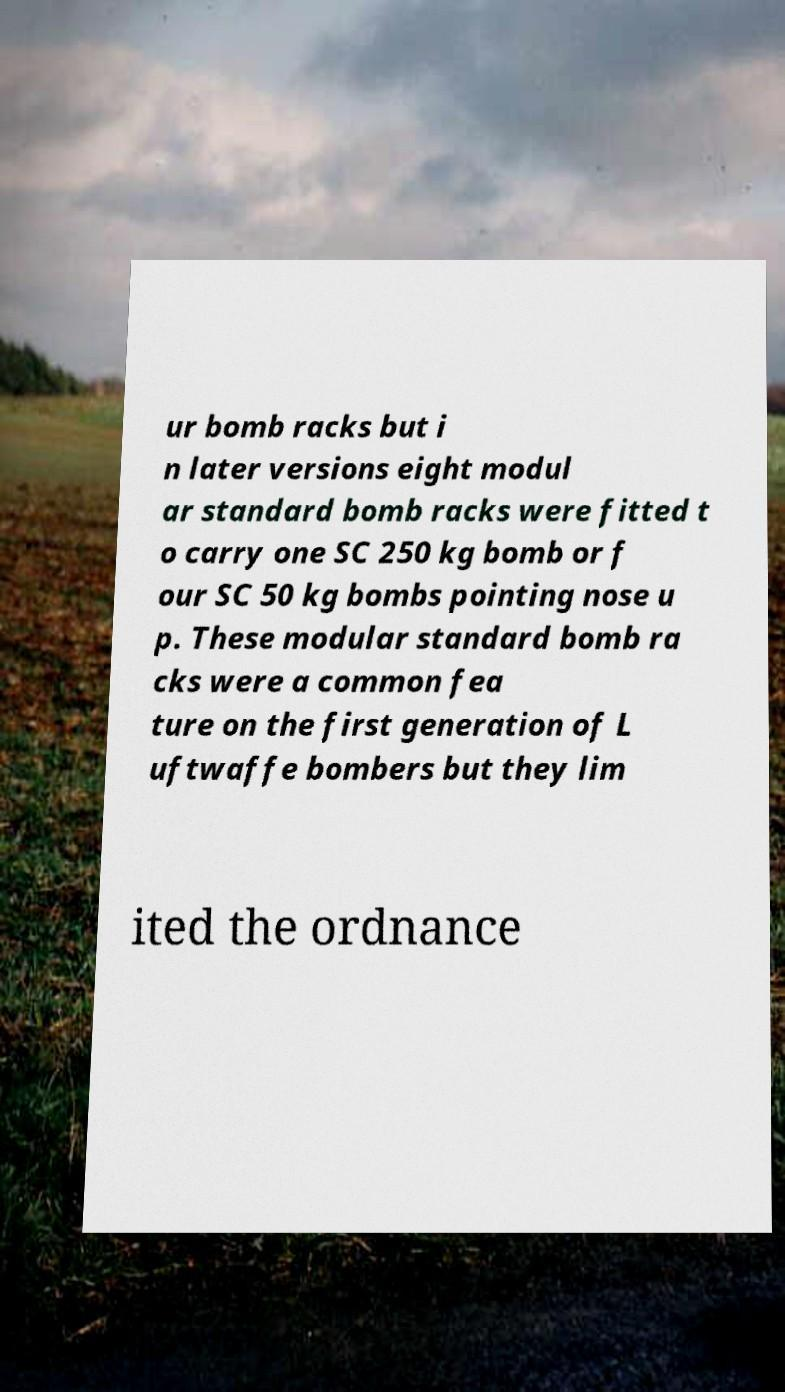What messages or text are displayed in this image? I need them in a readable, typed format. ur bomb racks but i n later versions eight modul ar standard bomb racks were fitted t o carry one SC 250 kg bomb or f our SC 50 kg bombs pointing nose u p. These modular standard bomb ra cks were a common fea ture on the first generation of L uftwaffe bombers but they lim ited the ordnance 